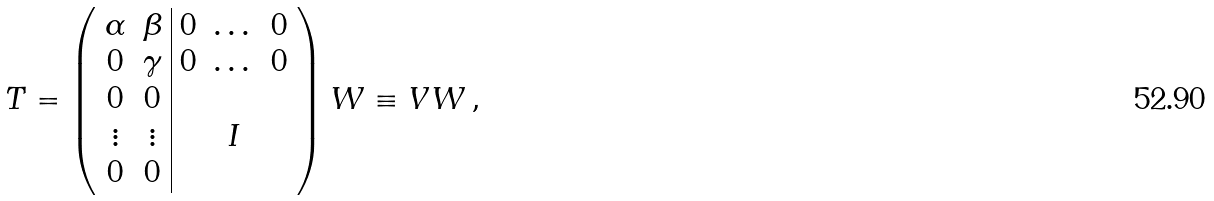Convert formula to latex. <formula><loc_0><loc_0><loc_500><loc_500>T = \left ( \begin{array} { c c | c c c } \alpha & \beta & 0 & \dots & 0 \\ 0 & \gamma & 0 & \dots & 0 \\ 0 & 0 & & & \\ \vdots & \vdots & & I & \\ 0 & 0 & & & \end{array} \right ) W \equiv V W \, ,</formula> 